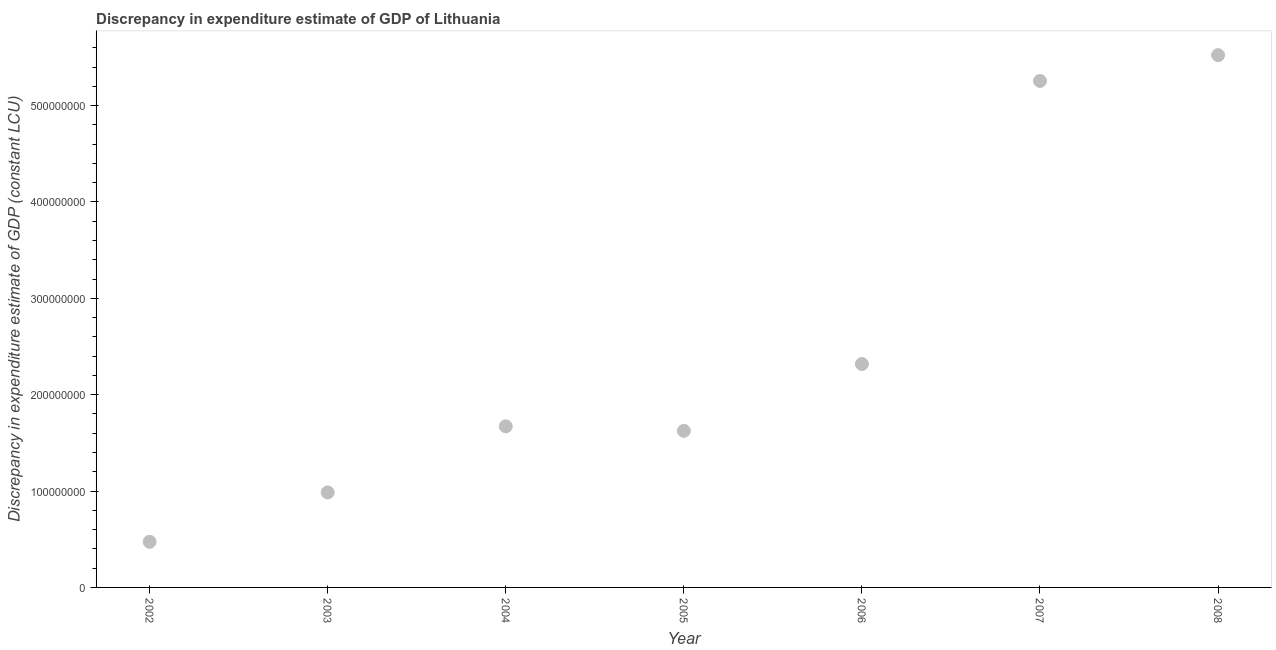What is the discrepancy in expenditure estimate of gdp in 2003?
Ensure brevity in your answer.  9.86e+07. Across all years, what is the maximum discrepancy in expenditure estimate of gdp?
Your answer should be compact. 5.52e+08. Across all years, what is the minimum discrepancy in expenditure estimate of gdp?
Your answer should be compact. 4.74e+07. What is the sum of the discrepancy in expenditure estimate of gdp?
Your answer should be very brief. 1.79e+09. What is the difference between the discrepancy in expenditure estimate of gdp in 2004 and 2008?
Your response must be concise. -3.85e+08. What is the average discrepancy in expenditure estimate of gdp per year?
Keep it short and to the point. 2.55e+08. What is the median discrepancy in expenditure estimate of gdp?
Your answer should be very brief. 1.67e+08. What is the ratio of the discrepancy in expenditure estimate of gdp in 2003 to that in 2004?
Offer a very short reply. 0.59. Is the discrepancy in expenditure estimate of gdp in 2003 less than that in 2007?
Your response must be concise. Yes. What is the difference between the highest and the second highest discrepancy in expenditure estimate of gdp?
Keep it short and to the point. 2.67e+07. Is the sum of the discrepancy in expenditure estimate of gdp in 2002 and 2008 greater than the maximum discrepancy in expenditure estimate of gdp across all years?
Provide a short and direct response. Yes. What is the difference between the highest and the lowest discrepancy in expenditure estimate of gdp?
Make the answer very short. 5.05e+08. In how many years, is the discrepancy in expenditure estimate of gdp greater than the average discrepancy in expenditure estimate of gdp taken over all years?
Your answer should be compact. 2. Are the values on the major ticks of Y-axis written in scientific E-notation?
Your response must be concise. No. Does the graph contain any zero values?
Ensure brevity in your answer.  No. Does the graph contain grids?
Offer a very short reply. No. What is the title of the graph?
Make the answer very short. Discrepancy in expenditure estimate of GDP of Lithuania. What is the label or title of the X-axis?
Give a very brief answer. Year. What is the label or title of the Y-axis?
Your response must be concise. Discrepancy in expenditure estimate of GDP (constant LCU). What is the Discrepancy in expenditure estimate of GDP (constant LCU) in 2002?
Your answer should be compact. 4.74e+07. What is the Discrepancy in expenditure estimate of GDP (constant LCU) in 2003?
Offer a very short reply. 9.86e+07. What is the Discrepancy in expenditure estimate of GDP (constant LCU) in 2004?
Give a very brief answer. 1.67e+08. What is the Discrepancy in expenditure estimate of GDP (constant LCU) in 2005?
Your answer should be very brief. 1.62e+08. What is the Discrepancy in expenditure estimate of GDP (constant LCU) in 2006?
Provide a succinct answer. 2.32e+08. What is the Discrepancy in expenditure estimate of GDP (constant LCU) in 2007?
Your answer should be compact. 5.26e+08. What is the Discrepancy in expenditure estimate of GDP (constant LCU) in 2008?
Keep it short and to the point. 5.52e+08. What is the difference between the Discrepancy in expenditure estimate of GDP (constant LCU) in 2002 and 2003?
Offer a terse response. -5.12e+07. What is the difference between the Discrepancy in expenditure estimate of GDP (constant LCU) in 2002 and 2004?
Keep it short and to the point. -1.20e+08. What is the difference between the Discrepancy in expenditure estimate of GDP (constant LCU) in 2002 and 2005?
Your answer should be compact. -1.15e+08. What is the difference between the Discrepancy in expenditure estimate of GDP (constant LCU) in 2002 and 2006?
Keep it short and to the point. -1.84e+08. What is the difference between the Discrepancy in expenditure estimate of GDP (constant LCU) in 2002 and 2007?
Offer a terse response. -4.78e+08. What is the difference between the Discrepancy in expenditure estimate of GDP (constant LCU) in 2002 and 2008?
Offer a very short reply. -5.05e+08. What is the difference between the Discrepancy in expenditure estimate of GDP (constant LCU) in 2003 and 2004?
Make the answer very short. -6.86e+07. What is the difference between the Discrepancy in expenditure estimate of GDP (constant LCU) in 2003 and 2005?
Provide a short and direct response. -6.39e+07. What is the difference between the Discrepancy in expenditure estimate of GDP (constant LCU) in 2003 and 2006?
Provide a short and direct response. -1.33e+08. What is the difference between the Discrepancy in expenditure estimate of GDP (constant LCU) in 2003 and 2007?
Your answer should be very brief. -4.27e+08. What is the difference between the Discrepancy in expenditure estimate of GDP (constant LCU) in 2003 and 2008?
Offer a very short reply. -4.54e+08. What is the difference between the Discrepancy in expenditure estimate of GDP (constant LCU) in 2004 and 2005?
Provide a succinct answer. 4.72e+06. What is the difference between the Discrepancy in expenditure estimate of GDP (constant LCU) in 2004 and 2006?
Provide a short and direct response. -6.47e+07. What is the difference between the Discrepancy in expenditure estimate of GDP (constant LCU) in 2004 and 2007?
Your answer should be compact. -3.58e+08. What is the difference between the Discrepancy in expenditure estimate of GDP (constant LCU) in 2004 and 2008?
Keep it short and to the point. -3.85e+08. What is the difference between the Discrepancy in expenditure estimate of GDP (constant LCU) in 2005 and 2006?
Provide a succinct answer. -6.94e+07. What is the difference between the Discrepancy in expenditure estimate of GDP (constant LCU) in 2005 and 2007?
Provide a short and direct response. -3.63e+08. What is the difference between the Discrepancy in expenditure estimate of GDP (constant LCU) in 2005 and 2008?
Provide a succinct answer. -3.90e+08. What is the difference between the Discrepancy in expenditure estimate of GDP (constant LCU) in 2006 and 2007?
Offer a terse response. -2.94e+08. What is the difference between the Discrepancy in expenditure estimate of GDP (constant LCU) in 2006 and 2008?
Ensure brevity in your answer.  -3.20e+08. What is the difference between the Discrepancy in expenditure estimate of GDP (constant LCU) in 2007 and 2008?
Ensure brevity in your answer.  -2.67e+07. What is the ratio of the Discrepancy in expenditure estimate of GDP (constant LCU) in 2002 to that in 2003?
Offer a very short reply. 0.48. What is the ratio of the Discrepancy in expenditure estimate of GDP (constant LCU) in 2002 to that in 2004?
Ensure brevity in your answer.  0.28. What is the ratio of the Discrepancy in expenditure estimate of GDP (constant LCU) in 2002 to that in 2005?
Provide a short and direct response. 0.29. What is the ratio of the Discrepancy in expenditure estimate of GDP (constant LCU) in 2002 to that in 2006?
Your response must be concise. 0.2. What is the ratio of the Discrepancy in expenditure estimate of GDP (constant LCU) in 2002 to that in 2007?
Your response must be concise. 0.09. What is the ratio of the Discrepancy in expenditure estimate of GDP (constant LCU) in 2002 to that in 2008?
Ensure brevity in your answer.  0.09. What is the ratio of the Discrepancy in expenditure estimate of GDP (constant LCU) in 2003 to that in 2004?
Ensure brevity in your answer.  0.59. What is the ratio of the Discrepancy in expenditure estimate of GDP (constant LCU) in 2003 to that in 2005?
Your response must be concise. 0.61. What is the ratio of the Discrepancy in expenditure estimate of GDP (constant LCU) in 2003 to that in 2006?
Ensure brevity in your answer.  0.42. What is the ratio of the Discrepancy in expenditure estimate of GDP (constant LCU) in 2003 to that in 2007?
Your response must be concise. 0.19. What is the ratio of the Discrepancy in expenditure estimate of GDP (constant LCU) in 2003 to that in 2008?
Offer a very short reply. 0.18. What is the ratio of the Discrepancy in expenditure estimate of GDP (constant LCU) in 2004 to that in 2005?
Give a very brief answer. 1.03. What is the ratio of the Discrepancy in expenditure estimate of GDP (constant LCU) in 2004 to that in 2006?
Provide a succinct answer. 0.72. What is the ratio of the Discrepancy in expenditure estimate of GDP (constant LCU) in 2004 to that in 2007?
Offer a very short reply. 0.32. What is the ratio of the Discrepancy in expenditure estimate of GDP (constant LCU) in 2004 to that in 2008?
Keep it short and to the point. 0.3. What is the ratio of the Discrepancy in expenditure estimate of GDP (constant LCU) in 2005 to that in 2006?
Give a very brief answer. 0.7. What is the ratio of the Discrepancy in expenditure estimate of GDP (constant LCU) in 2005 to that in 2007?
Give a very brief answer. 0.31. What is the ratio of the Discrepancy in expenditure estimate of GDP (constant LCU) in 2005 to that in 2008?
Provide a succinct answer. 0.29. What is the ratio of the Discrepancy in expenditure estimate of GDP (constant LCU) in 2006 to that in 2007?
Provide a succinct answer. 0.44. What is the ratio of the Discrepancy in expenditure estimate of GDP (constant LCU) in 2006 to that in 2008?
Provide a short and direct response. 0.42. 